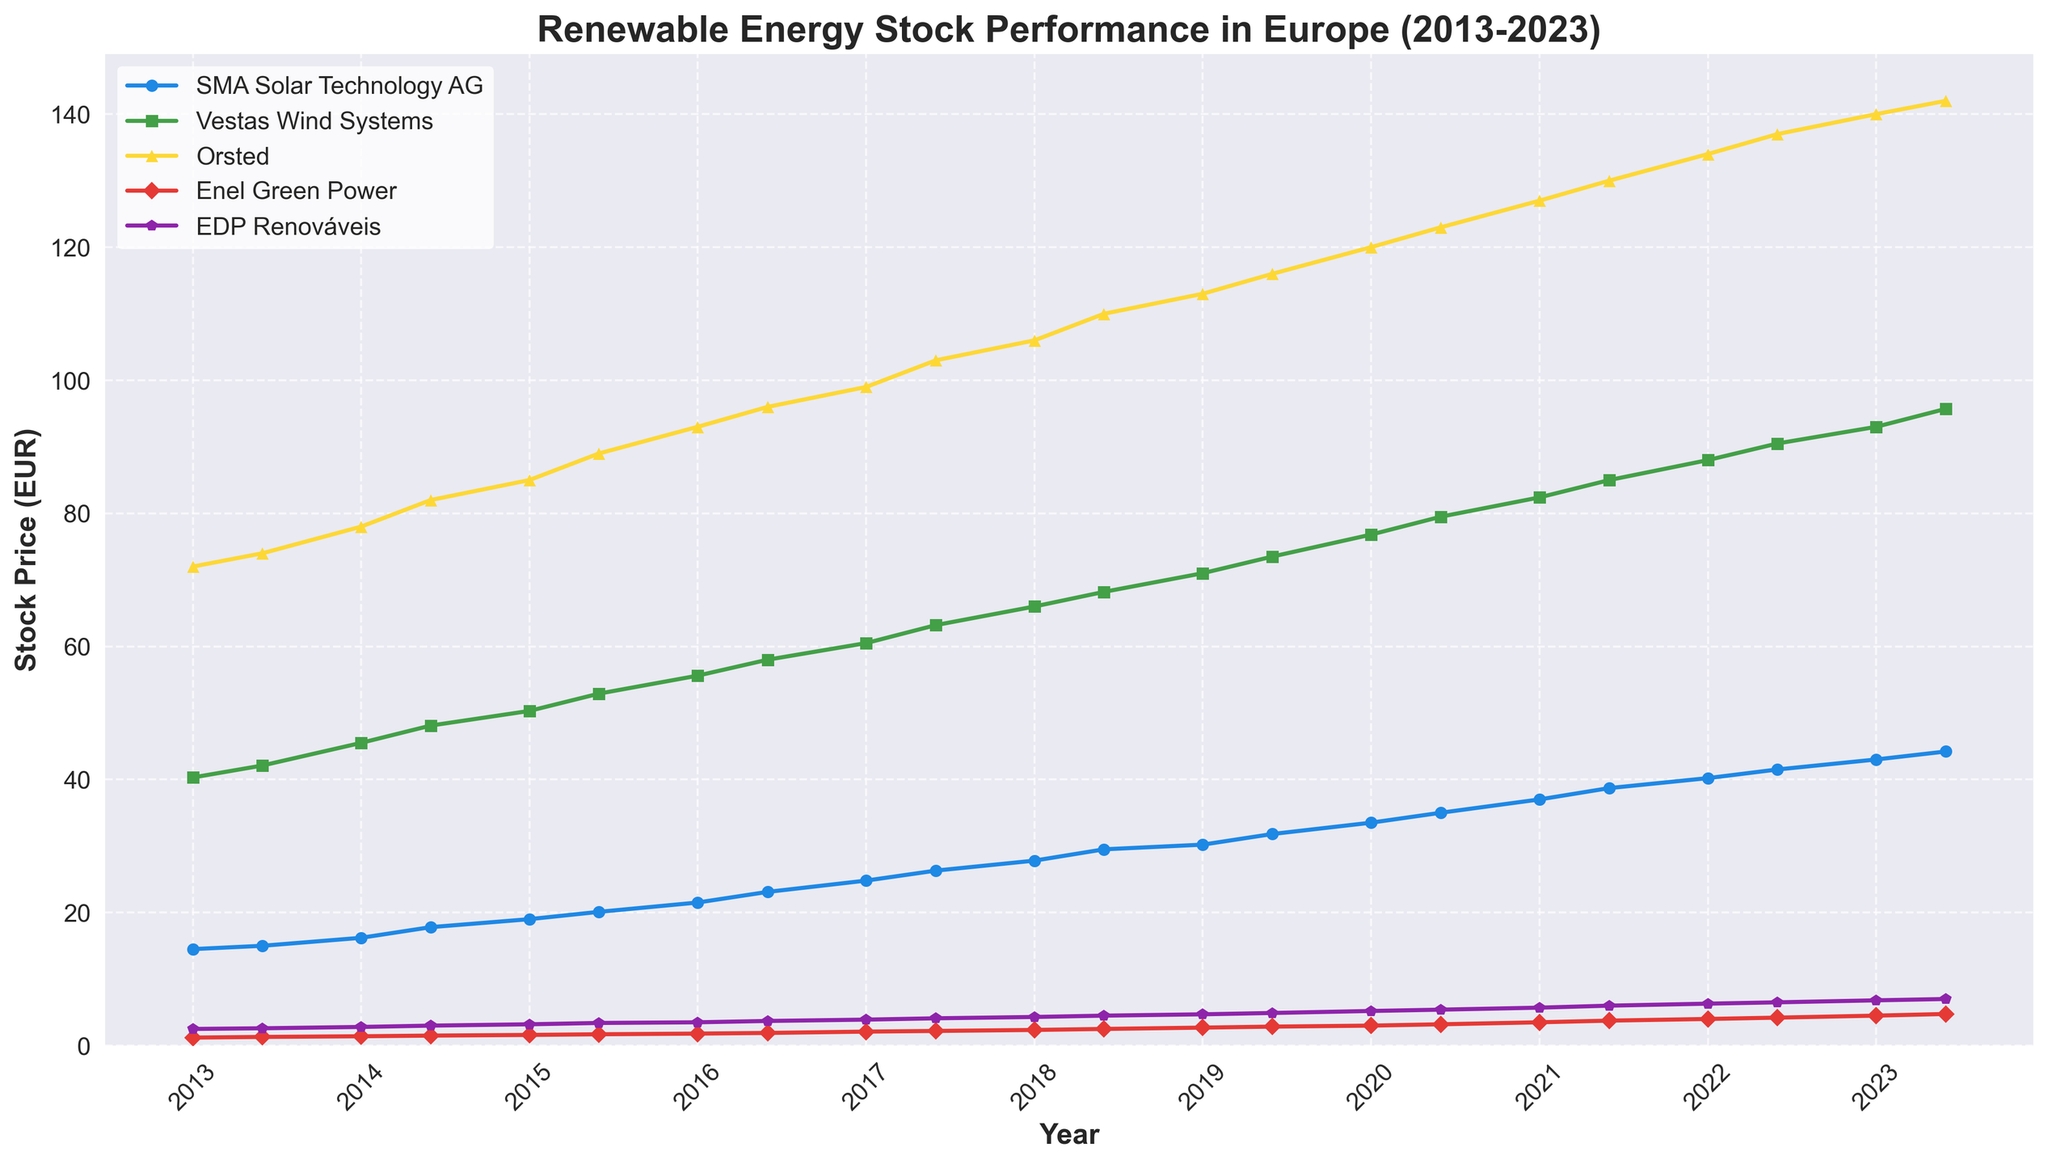When did the stock price of SMA Solar Technology AG reach 20 EUR for the first time? The stock price of SMA Solar Technology AG first surpassed 20 EUR in the range shown for June 2015. Looking at the plot, this is the first instance where the stock price reaches or exceeds 20 EUR.
Answer: June 2015 Which company had the highest stock price in 2023 (January)? To find out which company had the highest stock price in January 2023, we check the stock prices of all five companies at this date. The highest stock price is associated with Orsted.
Answer: Orsted How does the stock price of Vestas Wind Systems in January 2020 compare to that in January 2023? First, get the stock prices of Vestas Wind Systems for January 2020 and January 2023 from the figure. The stock price in January 2020 is 76.80 EUR and in January 2023, it is 93.00 EUR. Comparing the two, the stock price increased.
Answer: Increased Which company showed the most consistent growth over the decade? To determine the company with the most consistent growth, visually inspect the slope and stability of each company's line plot. EDP Renováveis shows a steady and consistent increase from 2013 to 2023 without much fluctuation.
Answer: EDP Renováveis Between 2015 and 2020, which company's stock price doubled? To determine if a company's stock price doubled between 2015 and 2020, check their stock prices at the start and end of this period. SMA Solar Technology AG's price increased from around 19 EUR in January 2015 to 38.70 EUR in June 2021, demonstrating more than a doubling.
Answer: SMA Solar Technology AG Which company had the largest percentage increase in stock price from June 2015 to June 2023? Identify the stock prices for each company for June 2015 and June 2023, then calculate the percentage increase. Orsted's stock price increased from 89.00 EUR to 142.00 EUR: ((142 - 89) / 89) * 100% ≈ 59.55%. This is the highest among the companies.
Answer: Orsted What is the trend of Enel Green Power's stock price from 2013 to 2023? To understand the trend, trace the line representing Enel Green Power. The stock price shows a steady and consistent increase over the decade, moving from 1.20 EUR to 4.75 EUR.
Answer: Steady Increase How did Vestas Wind Systems and EDP Renováveis' stock prices compare in January 2018? Check the stock prices for Vestas Wind Systems and EDP Renováveis in January 2018 from the plot. Vestas Wind Systems was 66.00 EUR, and EDP Renováveis was 4.30 EUR. Vestas Wind Systems had a significantly higher stock price.
Answer: Vestas Wind Systems had a higher stock price Between Vestas Wind Systems and SMA Solar Technology AG, which had a faster growth rate from 2013 to 2016? Calculate the growth rate for both companies over these years. Vestas Wind Systems increased from 40.30 EUR to 58.00 EUR = (58.00 - 40.30) / 40.30 ≈ 0.4397, or ~ 43.97%. SMA Solar Technology AG increased from 14.50 EUR to 23.10 EUR = (23.10 - 14.50) / 14.50 ≈ 0.5931, or ~ 59.31%. Therefore, SMA Solar Technology AG had a faster growth rate.
Answer: SMA Solar Technology AG 